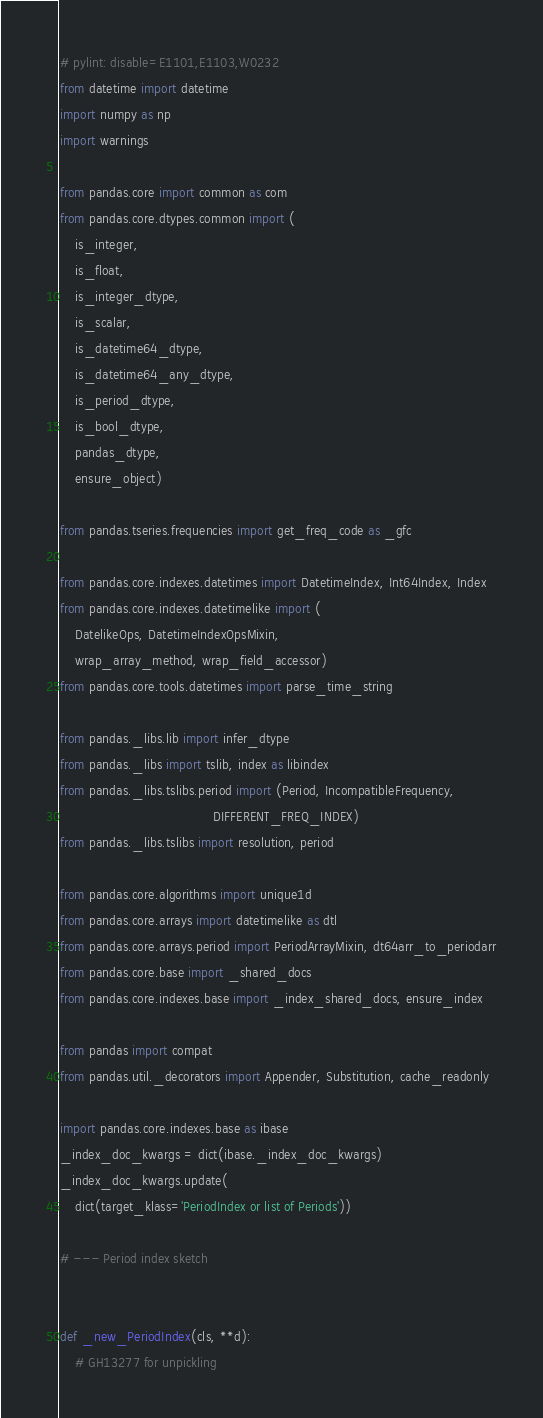<code> <loc_0><loc_0><loc_500><loc_500><_Python_># pylint: disable=E1101,E1103,W0232
from datetime import datetime
import numpy as np
import warnings

from pandas.core import common as com
from pandas.core.dtypes.common import (
    is_integer,
    is_float,
    is_integer_dtype,
    is_scalar,
    is_datetime64_dtype,
    is_datetime64_any_dtype,
    is_period_dtype,
    is_bool_dtype,
    pandas_dtype,
    ensure_object)

from pandas.tseries.frequencies import get_freq_code as _gfc

from pandas.core.indexes.datetimes import DatetimeIndex, Int64Index, Index
from pandas.core.indexes.datetimelike import (
    DatelikeOps, DatetimeIndexOpsMixin,
    wrap_array_method, wrap_field_accessor)
from pandas.core.tools.datetimes import parse_time_string

from pandas._libs.lib import infer_dtype
from pandas._libs import tslib, index as libindex
from pandas._libs.tslibs.period import (Period, IncompatibleFrequency,
                                        DIFFERENT_FREQ_INDEX)
from pandas._libs.tslibs import resolution, period

from pandas.core.algorithms import unique1d
from pandas.core.arrays import datetimelike as dtl
from pandas.core.arrays.period import PeriodArrayMixin, dt64arr_to_periodarr
from pandas.core.base import _shared_docs
from pandas.core.indexes.base import _index_shared_docs, ensure_index

from pandas import compat
from pandas.util._decorators import Appender, Substitution, cache_readonly

import pandas.core.indexes.base as ibase
_index_doc_kwargs = dict(ibase._index_doc_kwargs)
_index_doc_kwargs.update(
    dict(target_klass='PeriodIndex or list of Periods'))

# --- Period index sketch


def _new_PeriodIndex(cls, **d):
    # GH13277 for unpickling</code> 